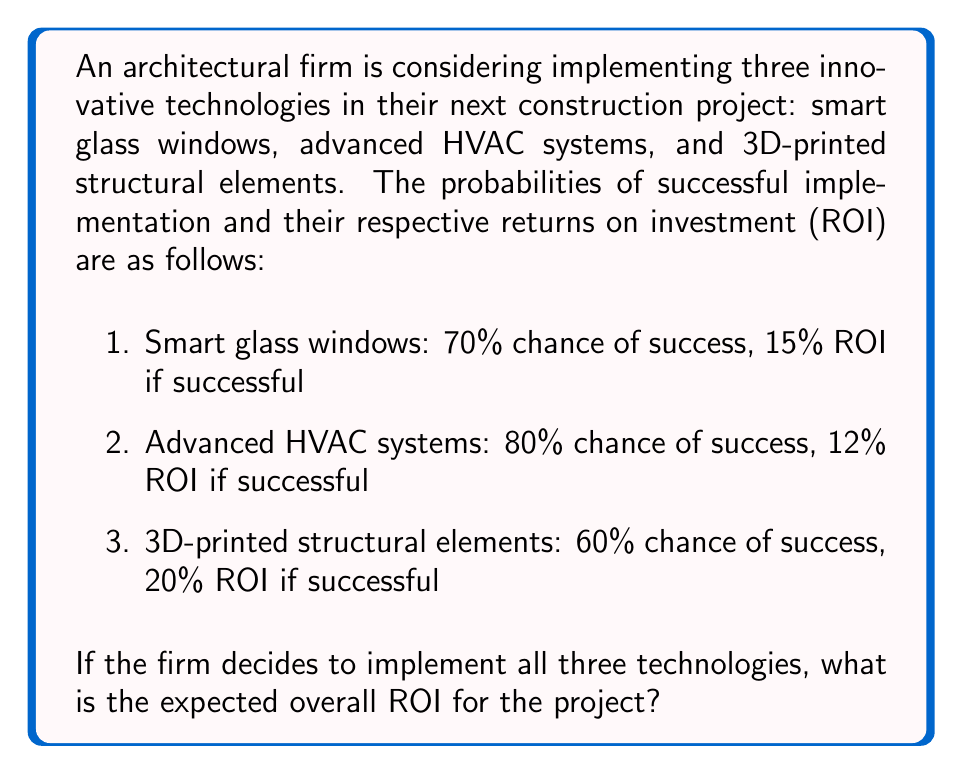Solve this math problem. To solve this problem, we need to calculate the expected value of the ROI for each technology and then sum them up. The expected value is calculated by multiplying the probability of success by the ROI if successful.

1. Smart glass windows:
   Expected ROI = Probability of success × ROI if successful
   $EV_{smart glass} = 0.70 \times 0.15 = 0.105 = 10.5\%$

2. Advanced HVAC systems:
   $EV_{HVAC} = 0.80 \times 0.12 = 0.096 = 9.6\%$

3. 3D-printed structural elements:
   $EV_{3D-printed} = 0.60 \times 0.20 = 0.12 = 12\%$

Now, we sum up the expected ROIs of all three technologies:

$EV_{total} = EV_{smart glass} + EV_{HVAC} + EV_{3D-printed}$
$EV_{total} = 0.105 + 0.096 + 0.12 = 0.321 = 32.1\%$

Therefore, the expected overall ROI for implementing all three innovative technologies in the construction project is 32.1%.
Answer: 32.1% 